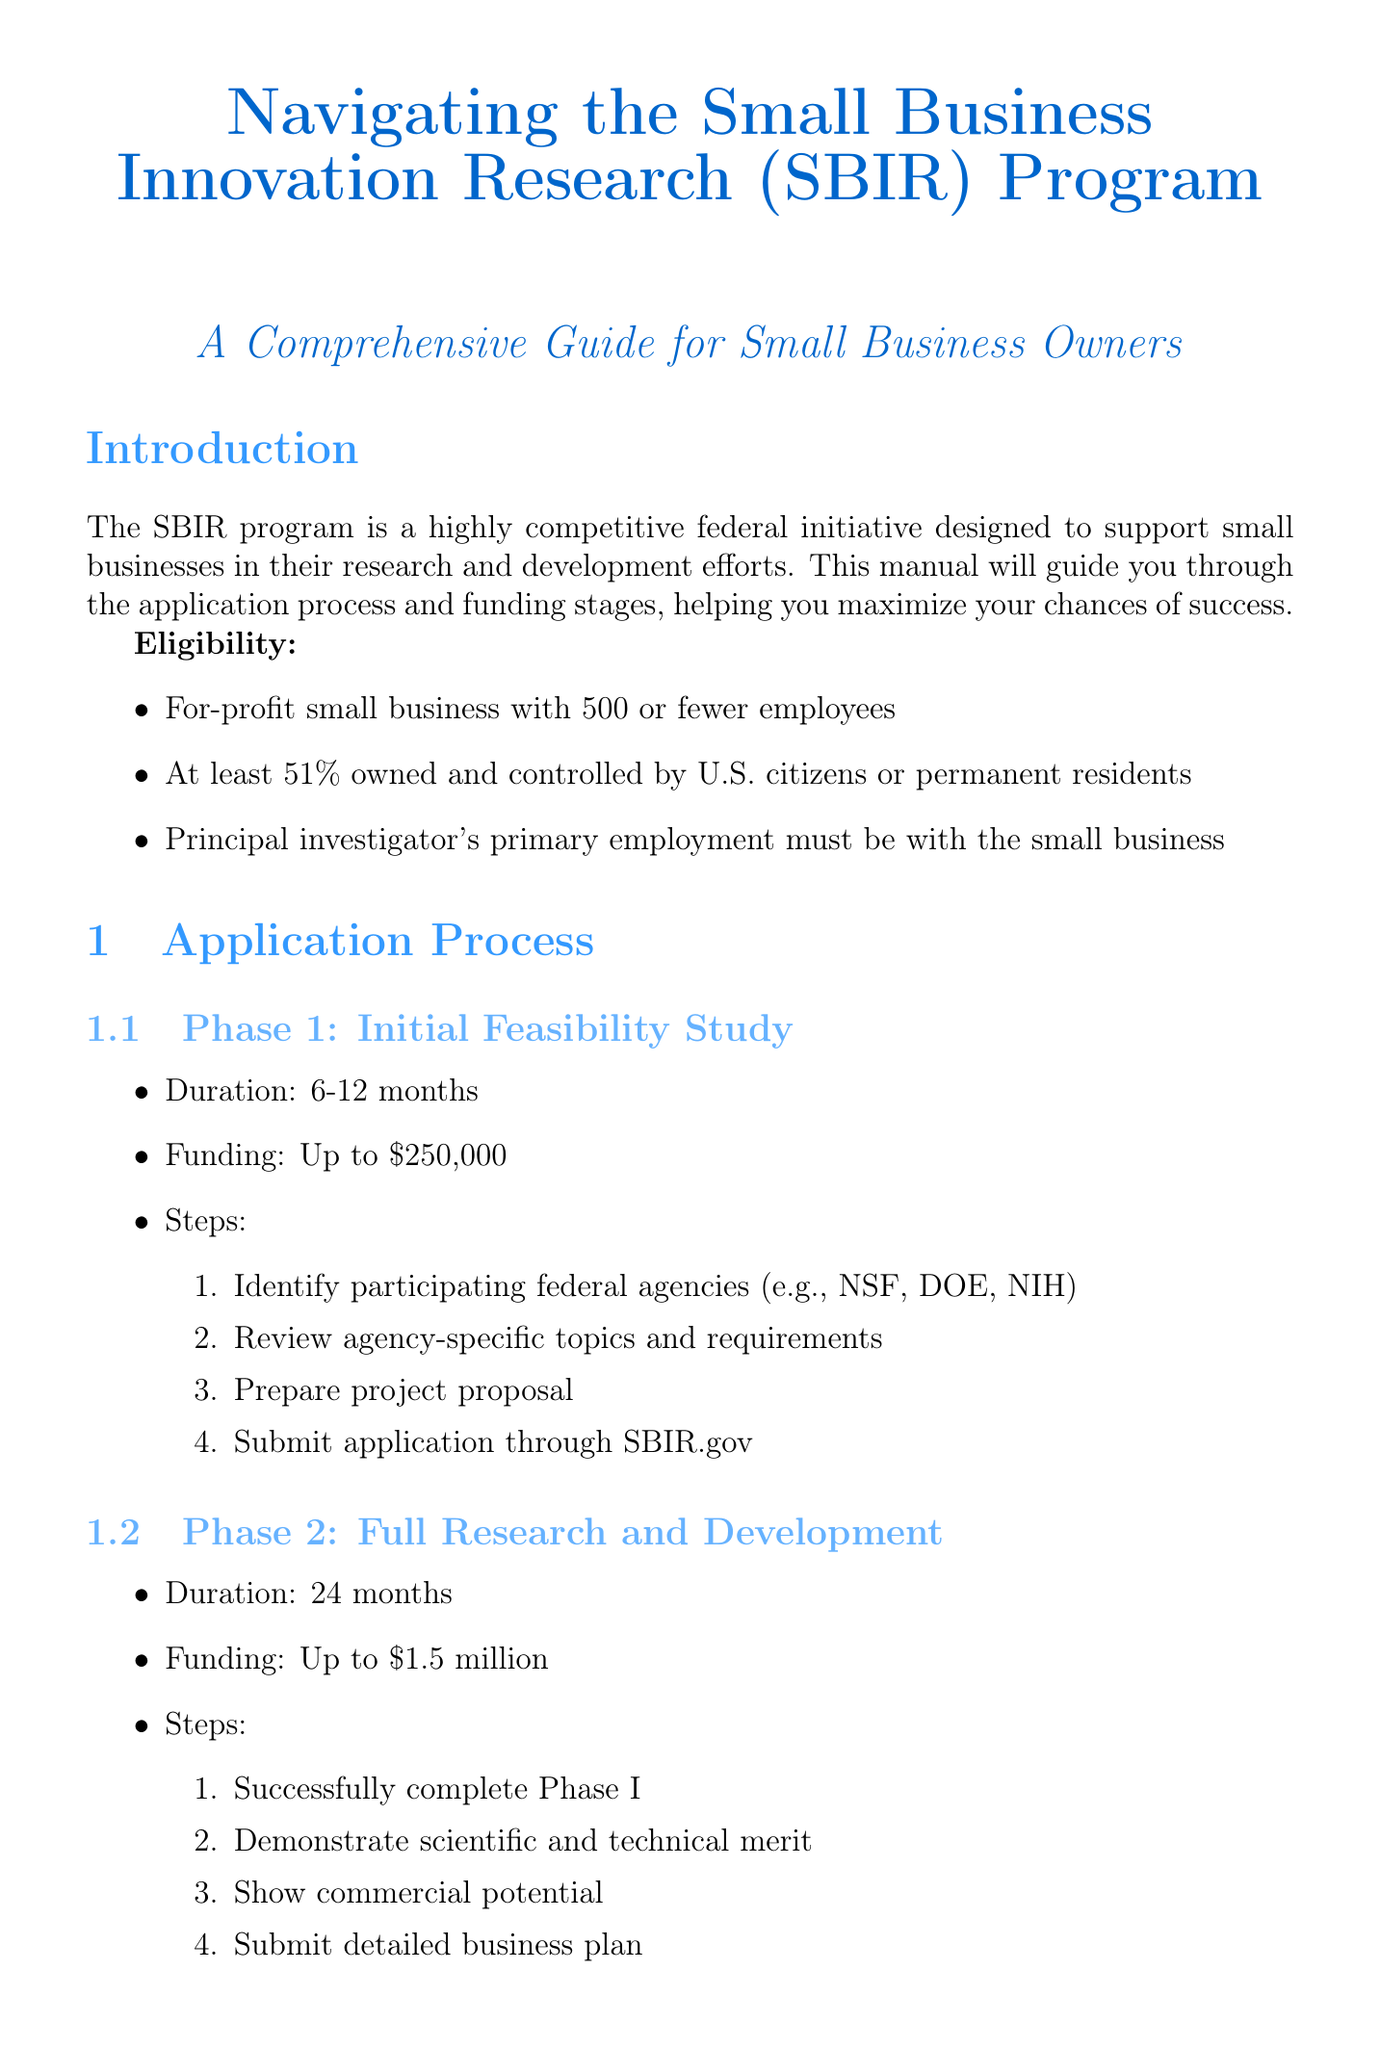What is the maximum funding for Phase 1? The maximum funding amount for Phase 1 is specified in the document under Phase 1: Initial Feasibility Study.
Answer: Up to $250,000 What is required to be eligible for the SBIR program? The eligibility criteria stated in the introduction outline what businesses qualify for the SBIR program.
Answer: For-profit small business with 500 or fewer employees What are the main steps for submitting a Phase 1 application? The steps to submit a Phase 1 application can be found under the application process, specifically for Phase 1.
Answer: Identify participating federal agencies; Review agency-specific topics and requirements; Prepare project proposal; Submit application through SBIR.gov What is the duration of Phase 2? The duration for Phase 2 is mentioned in the application process section that covers Phase 2.
Answer: 24 months What are the evaluation criteria for proposals? The criteria used to evaluate the proposals are listed in the evaluation criteria section.
Answer: Innovation and technical merit Can you apply for Phase 2 funding from a different agency? The document states what happens if a Phase I project is not selected for Phase II funding, which addresses this question.
Answer: Yes What type of support programs are listed? Support programs available for small businesses are outlined under the resources section of the document.
Answer: Small Business Development Centers; Procurement Technical Assistance Centers; SCORE mentorship program What is the outcome of Qualcomm's SBIR project? The case studies section provides outcomes for specific companies involved in SBIR projects.
Answer: Became a global leader in wireless technology 